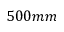Convert formula to latex. <formula><loc_0><loc_0><loc_500><loc_500>5 0 0 m m</formula> 